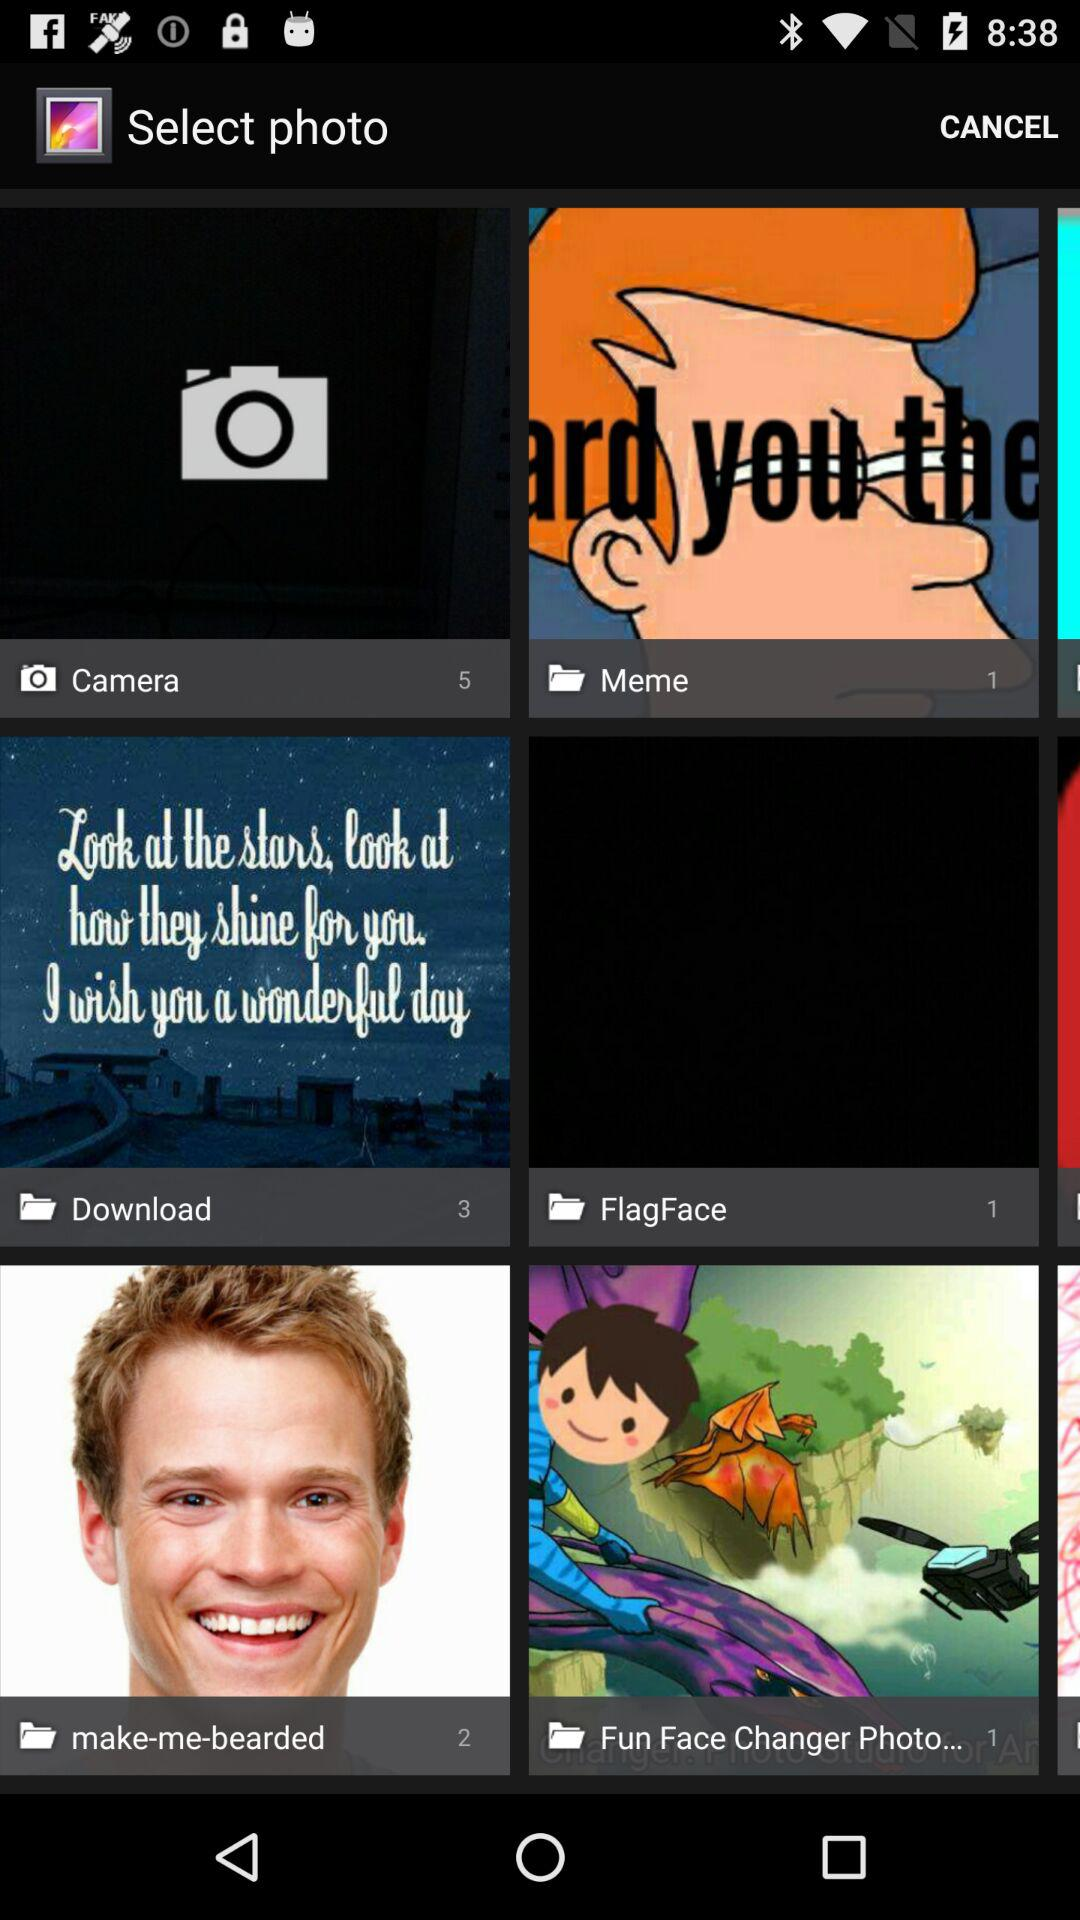How many pics are there in the download folder? There are 3 pics in the download folder. 